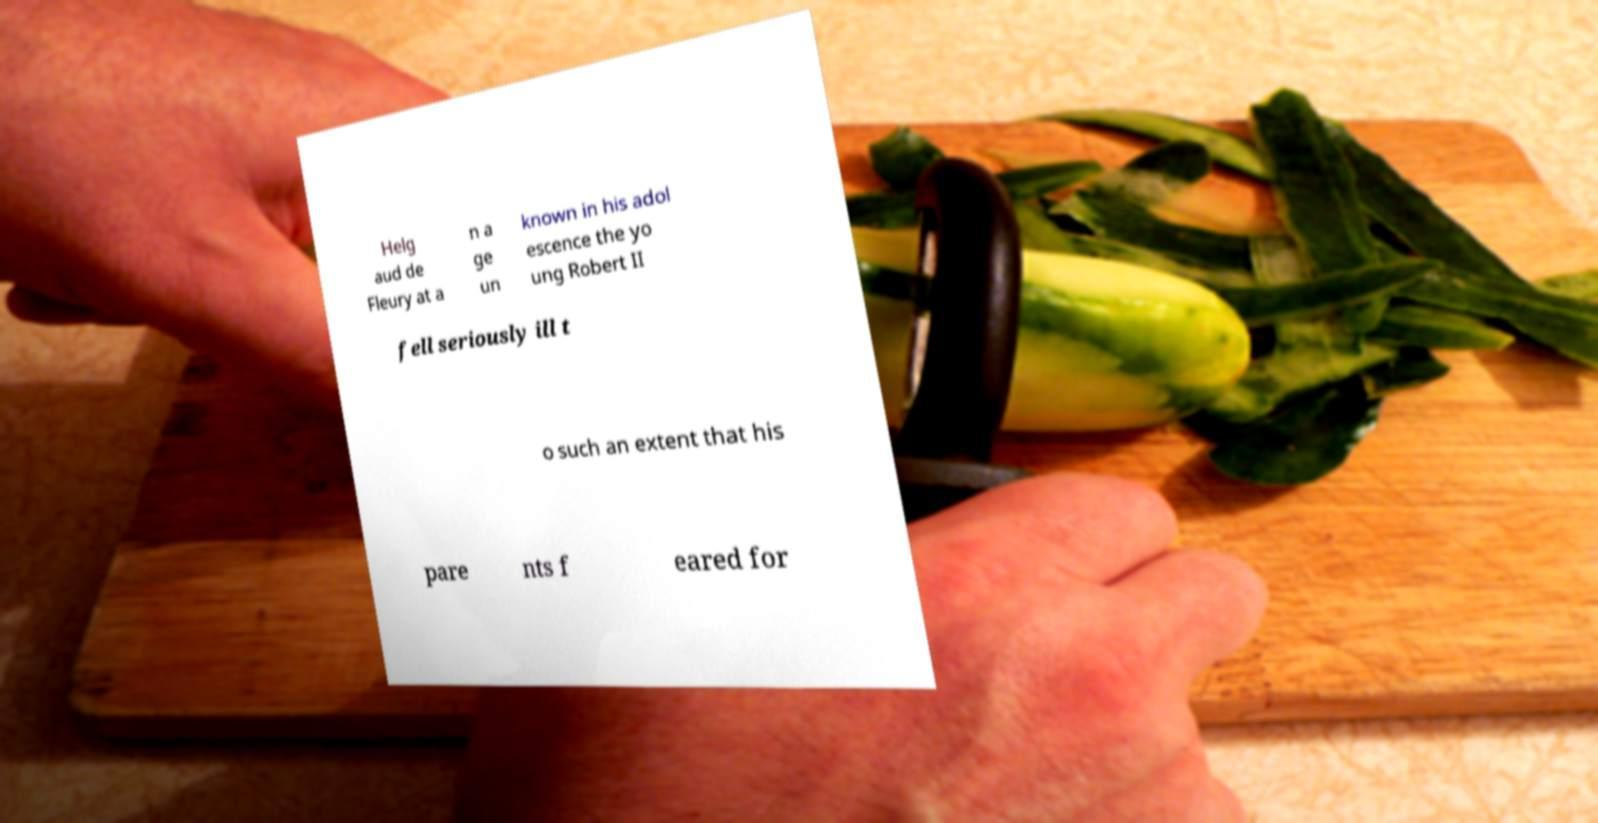There's text embedded in this image that I need extracted. Can you transcribe it verbatim? Helg aud de Fleury at a n a ge un known in his adol escence the yo ung Robert II fell seriously ill t o such an extent that his pare nts f eared for 